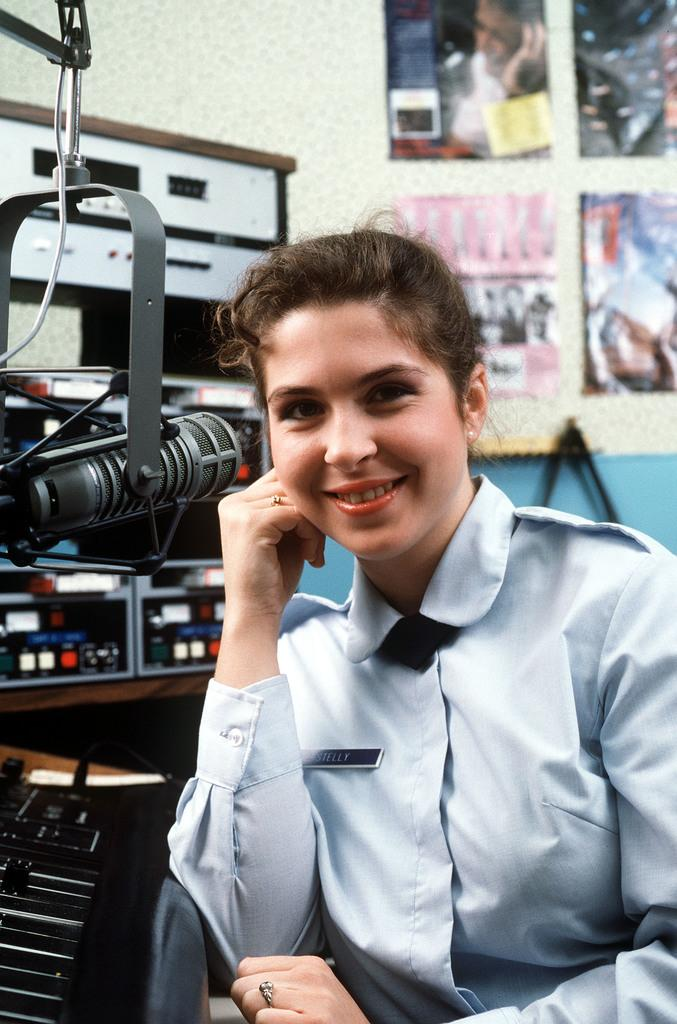Who is present in the image? There is a woman in the image. What can be seen in the background of the image? There are machines, metal objects, and photo frames on a wall in the background of the image. What might be the location of the image? The image might have been taken in a hall. What is the rate of the industry in the image? There is no industry present in the image, so it is not possible to determine the rate of any industry. 